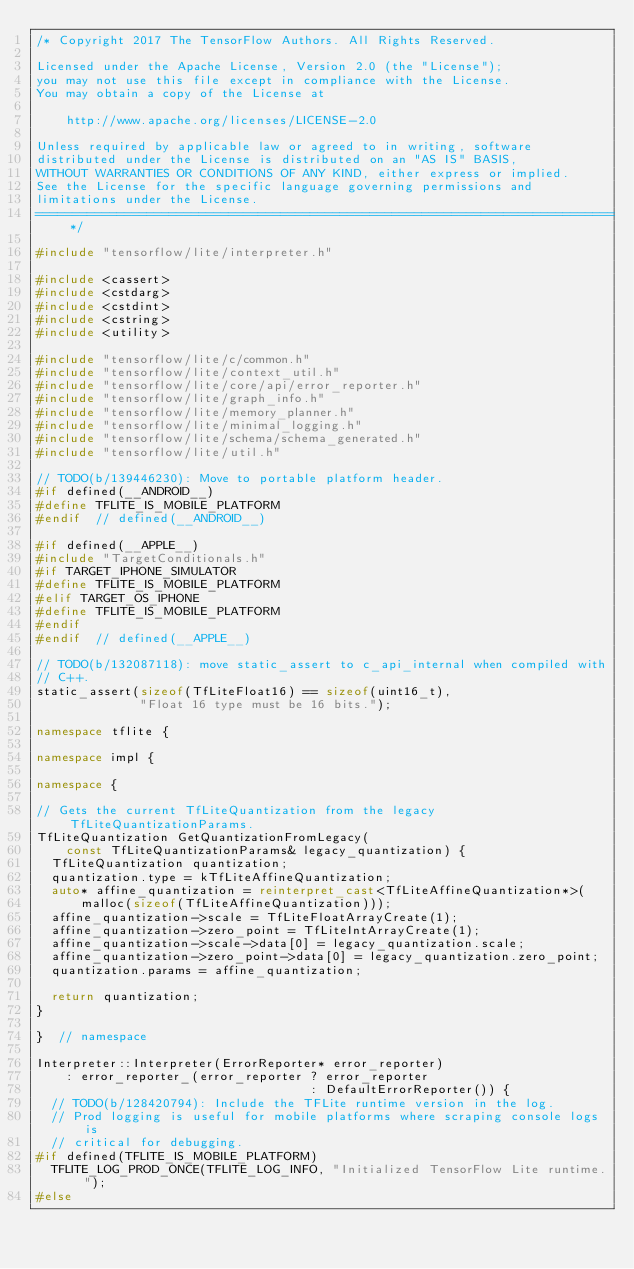Convert code to text. <code><loc_0><loc_0><loc_500><loc_500><_C++_>/* Copyright 2017 The TensorFlow Authors. All Rights Reserved.

Licensed under the Apache License, Version 2.0 (the "License");
you may not use this file except in compliance with the License.
You may obtain a copy of the License at

    http://www.apache.org/licenses/LICENSE-2.0

Unless required by applicable law or agreed to in writing, software
distributed under the License is distributed on an "AS IS" BASIS,
WITHOUT WARRANTIES OR CONDITIONS OF ANY KIND, either express or implied.
See the License for the specific language governing permissions and
limitations under the License.
==============================================================================*/

#include "tensorflow/lite/interpreter.h"

#include <cassert>
#include <cstdarg>
#include <cstdint>
#include <cstring>
#include <utility>

#include "tensorflow/lite/c/common.h"
#include "tensorflow/lite/context_util.h"
#include "tensorflow/lite/core/api/error_reporter.h"
#include "tensorflow/lite/graph_info.h"
#include "tensorflow/lite/memory_planner.h"
#include "tensorflow/lite/minimal_logging.h"
#include "tensorflow/lite/schema/schema_generated.h"
#include "tensorflow/lite/util.h"

// TODO(b/139446230): Move to portable platform header.
#if defined(__ANDROID__)
#define TFLITE_IS_MOBILE_PLATFORM
#endif  // defined(__ANDROID__)

#if defined(__APPLE__)
#include "TargetConditionals.h"
#if TARGET_IPHONE_SIMULATOR
#define TFLITE_IS_MOBILE_PLATFORM
#elif TARGET_OS_IPHONE
#define TFLITE_IS_MOBILE_PLATFORM
#endif
#endif  // defined(__APPLE__)

// TODO(b/132087118): move static_assert to c_api_internal when compiled with
// C++.
static_assert(sizeof(TfLiteFloat16) == sizeof(uint16_t),
              "Float 16 type must be 16 bits.");

namespace tflite {

namespace impl {

namespace {

// Gets the current TfLiteQuantization from the legacy TfLiteQuantizationParams.
TfLiteQuantization GetQuantizationFromLegacy(
    const TfLiteQuantizationParams& legacy_quantization) {
  TfLiteQuantization quantization;
  quantization.type = kTfLiteAffineQuantization;
  auto* affine_quantization = reinterpret_cast<TfLiteAffineQuantization*>(
      malloc(sizeof(TfLiteAffineQuantization)));
  affine_quantization->scale = TfLiteFloatArrayCreate(1);
  affine_quantization->zero_point = TfLiteIntArrayCreate(1);
  affine_quantization->scale->data[0] = legacy_quantization.scale;
  affine_quantization->zero_point->data[0] = legacy_quantization.zero_point;
  quantization.params = affine_quantization;

  return quantization;
}

}  // namespace

Interpreter::Interpreter(ErrorReporter* error_reporter)
    : error_reporter_(error_reporter ? error_reporter
                                     : DefaultErrorReporter()) {
  // TODO(b/128420794): Include the TFLite runtime version in the log.
  // Prod logging is useful for mobile platforms where scraping console logs is
  // critical for debugging.
#if defined(TFLITE_IS_MOBILE_PLATFORM)
  TFLITE_LOG_PROD_ONCE(TFLITE_LOG_INFO, "Initialized TensorFlow Lite runtime.");
#else</code> 